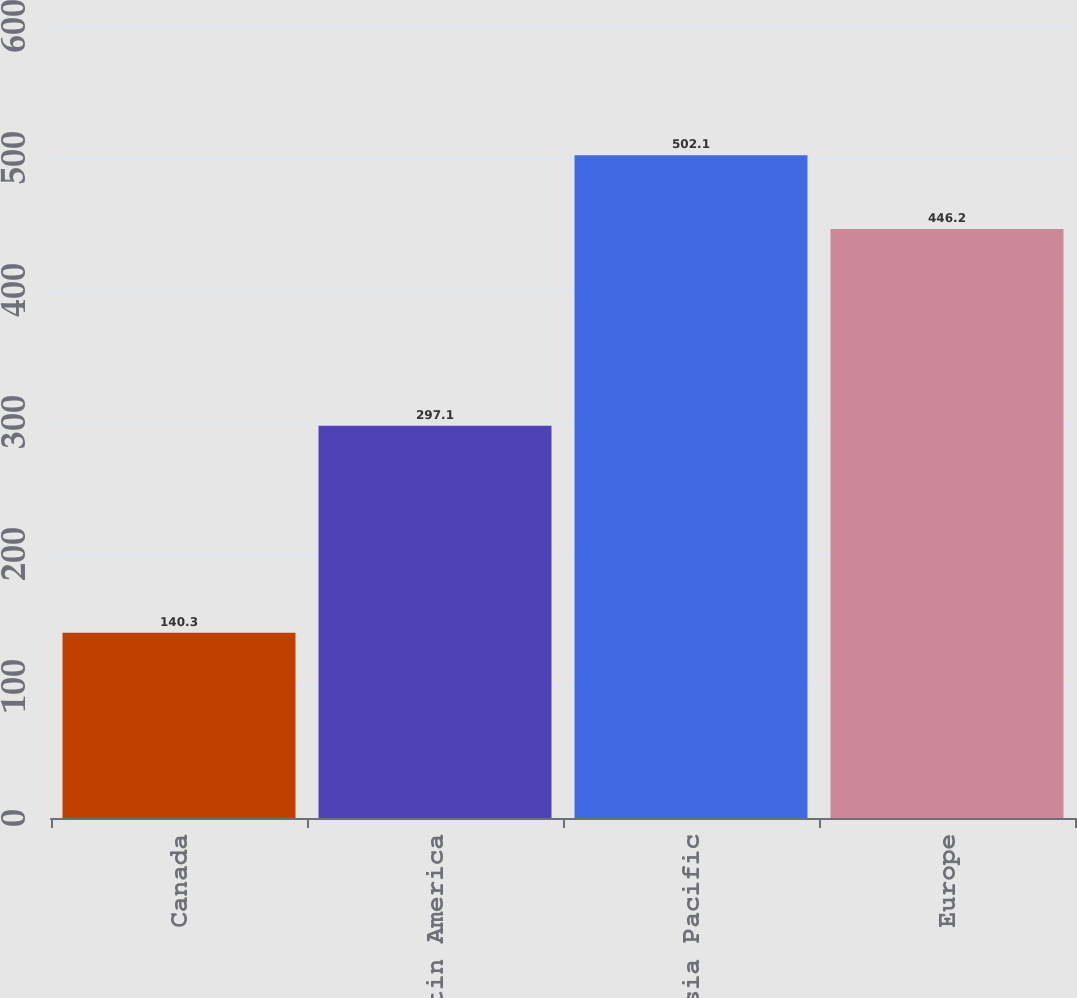Convert chart. <chart><loc_0><loc_0><loc_500><loc_500><bar_chart><fcel>Canada<fcel>Latin America<fcel>Asia Pacific<fcel>Europe<nl><fcel>140.3<fcel>297.1<fcel>502.1<fcel>446.2<nl></chart> 